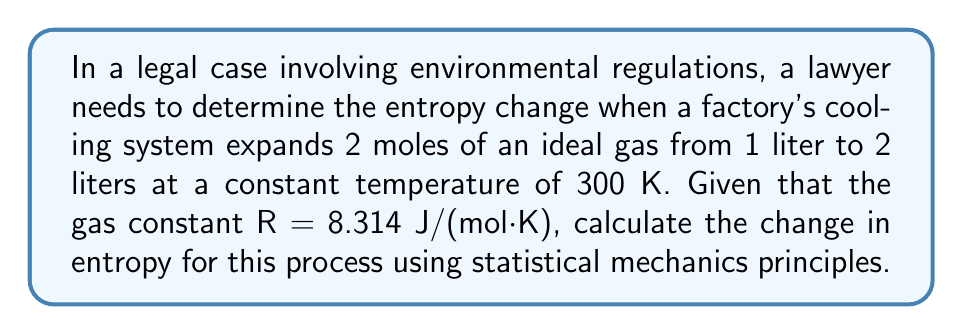What is the answer to this math problem? Let's approach this step-by-step using statistical mechanics:

1) In statistical mechanics, entropy S is related to the number of microstates Ω by the Boltzmann equation:

   $$S = k_B \ln \Omega$$

   where $k_B$ is the Boltzmann constant.

2) For an ideal gas, the number of microstates is proportional to the volume V:

   $$\Omega \propto V^N$$

   where N is the number of particles.

3) Therefore, the change in entropy when volume changes from $V_1$ to $V_2$ is:

   $$\Delta S = k_B \ln \frac{\Omega_2}{\Omega_1} = k_B \ln \frac{V_2^N}{V_1^N} = Nk_B \ln \frac{V_2}{V_1}$$

4) We can convert this to molar quantities by using Avogadro's number $N_A$:

   $$\Delta S = nN_Ak_B \ln \frac{V_2}{V_1} = nR \ln \frac{V_2}{V_1}$$

   where n is the number of moles and R is the gas constant.

5) Now, let's plug in our values:
   n = 2 moles
   $V_1$ = 1 liter
   $V_2$ = 2 liters
   R = 8.314 J/(mol·K)

   $$\Delta S = 2 \cdot 8.314 \cdot \ln \frac{2}{1} = 16.628 \cdot \ln 2 = 11.526 \text{ J/K}$$

Thus, the entropy change in this process is 11.526 J/K.
Answer: 11.526 J/K 